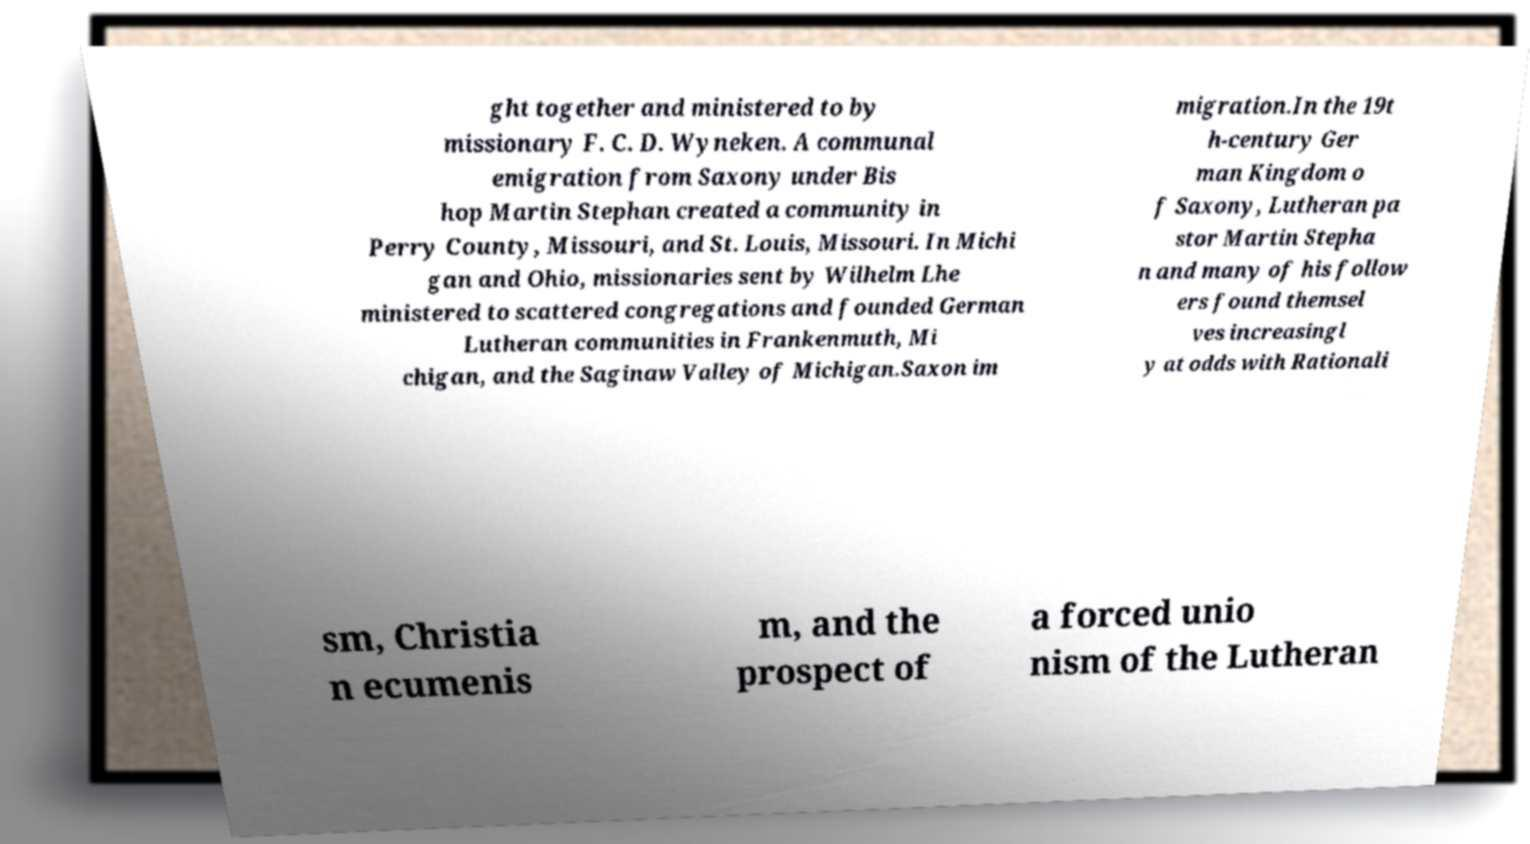What messages or text are displayed in this image? I need them in a readable, typed format. ght together and ministered to by missionary F. C. D. Wyneken. A communal emigration from Saxony under Bis hop Martin Stephan created a community in Perry County, Missouri, and St. Louis, Missouri. In Michi gan and Ohio, missionaries sent by Wilhelm Lhe ministered to scattered congregations and founded German Lutheran communities in Frankenmuth, Mi chigan, and the Saginaw Valley of Michigan.Saxon im migration.In the 19t h-century Ger man Kingdom o f Saxony, Lutheran pa stor Martin Stepha n and many of his follow ers found themsel ves increasingl y at odds with Rationali sm, Christia n ecumenis m, and the prospect of a forced unio nism of the Lutheran 